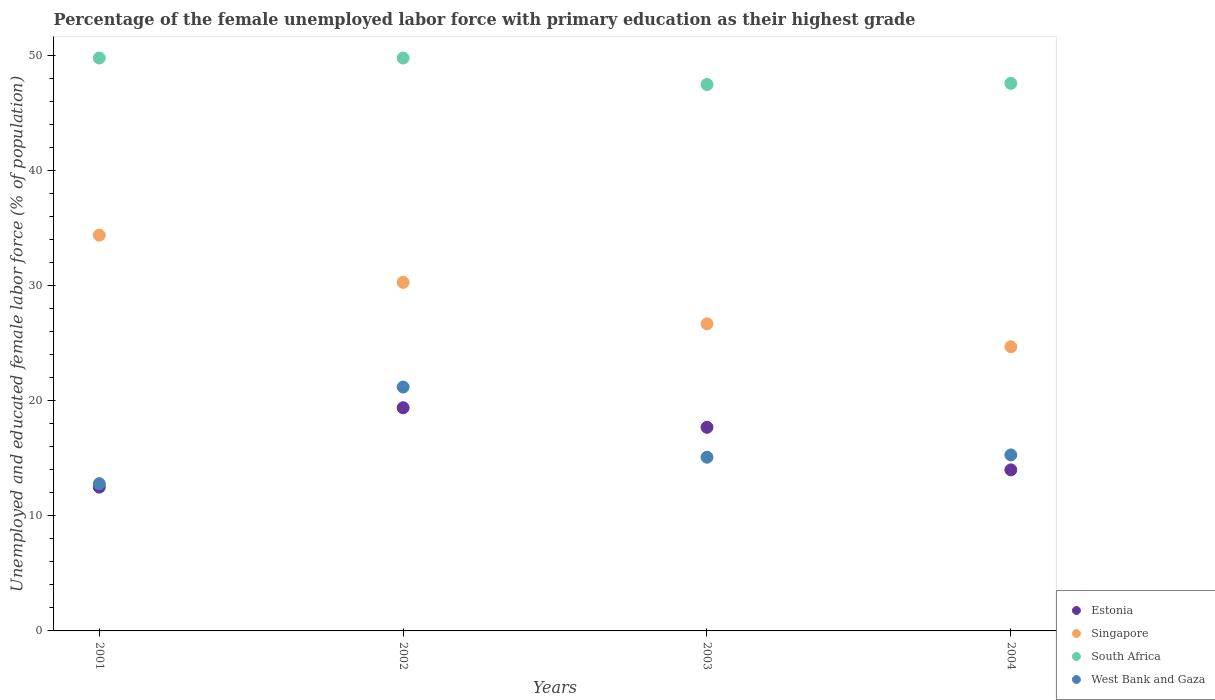How many different coloured dotlines are there?
Keep it short and to the point. 4. Is the number of dotlines equal to the number of legend labels?
Provide a short and direct response. Yes. What is the percentage of the unemployed female labor force with primary education in West Bank and Gaza in 2002?
Offer a very short reply. 21.2. Across all years, what is the maximum percentage of the unemployed female labor force with primary education in Singapore?
Offer a very short reply. 34.4. Across all years, what is the minimum percentage of the unemployed female labor force with primary education in South Africa?
Offer a very short reply. 47.5. In which year was the percentage of the unemployed female labor force with primary education in Singapore maximum?
Your response must be concise. 2001. What is the total percentage of the unemployed female labor force with primary education in South Africa in the graph?
Offer a very short reply. 194.7. What is the difference between the percentage of the unemployed female labor force with primary education in South Africa in 2001 and that in 2003?
Make the answer very short. 2.3. What is the difference between the percentage of the unemployed female labor force with primary education in Estonia in 2004 and the percentage of the unemployed female labor force with primary education in South Africa in 2002?
Provide a short and direct response. -35.8. What is the average percentage of the unemployed female labor force with primary education in Singapore per year?
Your answer should be very brief. 29.03. In the year 2004, what is the difference between the percentage of the unemployed female labor force with primary education in South Africa and percentage of the unemployed female labor force with primary education in Singapore?
Offer a very short reply. 22.9. What is the ratio of the percentage of the unemployed female labor force with primary education in Estonia in 2002 to that in 2004?
Your answer should be compact. 1.39. Is the percentage of the unemployed female labor force with primary education in South Africa in 2001 less than that in 2003?
Provide a short and direct response. No. Is the difference between the percentage of the unemployed female labor force with primary education in South Africa in 2002 and 2004 greater than the difference between the percentage of the unemployed female labor force with primary education in Singapore in 2002 and 2004?
Make the answer very short. No. What is the difference between the highest and the second highest percentage of the unemployed female labor force with primary education in South Africa?
Give a very brief answer. 0. What is the difference between the highest and the lowest percentage of the unemployed female labor force with primary education in South Africa?
Your response must be concise. 2.3. Is it the case that in every year, the sum of the percentage of the unemployed female labor force with primary education in Singapore and percentage of the unemployed female labor force with primary education in West Bank and Gaza  is greater than the sum of percentage of the unemployed female labor force with primary education in South Africa and percentage of the unemployed female labor force with primary education in Estonia?
Your answer should be compact. No. Is the percentage of the unemployed female labor force with primary education in Singapore strictly greater than the percentage of the unemployed female labor force with primary education in West Bank and Gaza over the years?
Your response must be concise. Yes. How many years are there in the graph?
Ensure brevity in your answer.  4. Does the graph contain any zero values?
Offer a very short reply. No. Does the graph contain grids?
Your response must be concise. No. Where does the legend appear in the graph?
Keep it short and to the point. Bottom right. How many legend labels are there?
Your response must be concise. 4. How are the legend labels stacked?
Your answer should be very brief. Vertical. What is the title of the graph?
Provide a short and direct response. Percentage of the female unemployed labor force with primary education as their highest grade. What is the label or title of the X-axis?
Offer a terse response. Years. What is the label or title of the Y-axis?
Make the answer very short. Unemployed and educated female labor force (% of population). What is the Unemployed and educated female labor force (% of population) of Estonia in 2001?
Make the answer very short. 12.5. What is the Unemployed and educated female labor force (% of population) of Singapore in 2001?
Your answer should be compact. 34.4. What is the Unemployed and educated female labor force (% of population) of South Africa in 2001?
Offer a very short reply. 49.8. What is the Unemployed and educated female labor force (% of population) in West Bank and Gaza in 2001?
Give a very brief answer. 12.8. What is the Unemployed and educated female labor force (% of population) of Estonia in 2002?
Offer a terse response. 19.4. What is the Unemployed and educated female labor force (% of population) in Singapore in 2002?
Provide a succinct answer. 30.3. What is the Unemployed and educated female labor force (% of population) in South Africa in 2002?
Make the answer very short. 49.8. What is the Unemployed and educated female labor force (% of population) of West Bank and Gaza in 2002?
Keep it short and to the point. 21.2. What is the Unemployed and educated female labor force (% of population) of Estonia in 2003?
Make the answer very short. 17.7. What is the Unemployed and educated female labor force (% of population) in Singapore in 2003?
Offer a very short reply. 26.7. What is the Unemployed and educated female labor force (% of population) in South Africa in 2003?
Offer a terse response. 47.5. What is the Unemployed and educated female labor force (% of population) of West Bank and Gaza in 2003?
Make the answer very short. 15.1. What is the Unemployed and educated female labor force (% of population) of Estonia in 2004?
Provide a short and direct response. 14. What is the Unemployed and educated female labor force (% of population) of Singapore in 2004?
Ensure brevity in your answer.  24.7. What is the Unemployed and educated female labor force (% of population) of South Africa in 2004?
Offer a very short reply. 47.6. What is the Unemployed and educated female labor force (% of population) in West Bank and Gaza in 2004?
Your answer should be very brief. 15.3. Across all years, what is the maximum Unemployed and educated female labor force (% of population) of Estonia?
Your answer should be compact. 19.4. Across all years, what is the maximum Unemployed and educated female labor force (% of population) in Singapore?
Offer a very short reply. 34.4. Across all years, what is the maximum Unemployed and educated female labor force (% of population) of South Africa?
Provide a succinct answer. 49.8. Across all years, what is the maximum Unemployed and educated female labor force (% of population) of West Bank and Gaza?
Provide a succinct answer. 21.2. Across all years, what is the minimum Unemployed and educated female labor force (% of population) in Estonia?
Ensure brevity in your answer.  12.5. Across all years, what is the minimum Unemployed and educated female labor force (% of population) of Singapore?
Ensure brevity in your answer.  24.7. Across all years, what is the minimum Unemployed and educated female labor force (% of population) of South Africa?
Offer a terse response. 47.5. Across all years, what is the minimum Unemployed and educated female labor force (% of population) of West Bank and Gaza?
Provide a short and direct response. 12.8. What is the total Unemployed and educated female labor force (% of population) of Estonia in the graph?
Keep it short and to the point. 63.6. What is the total Unemployed and educated female labor force (% of population) in Singapore in the graph?
Keep it short and to the point. 116.1. What is the total Unemployed and educated female labor force (% of population) in South Africa in the graph?
Your answer should be very brief. 194.7. What is the total Unemployed and educated female labor force (% of population) in West Bank and Gaza in the graph?
Provide a succinct answer. 64.4. What is the difference between the Unemployed and educated female labor force (% of population) in Estonia in 2001 and that in 2002?
Provide a short and direct response. -6.9. What is the difference between the Unemployed and educated female labor force (% of population) of Estonia in 2001 and that in 2003?
Your answer should be compact. -5.2. What is the difference between the Unemployed and educated female labor force (% of population) of Singapore in 2001 and that in 2003?
Your answer should be compact. 7.7. What is the difference between the Unemployed and educated female labor force (% of population) in South Africa in 2001 and that in 2003?
Your response must be concise. 2.3. What is the difference between the Unemployed and educated female labor force (% of population) in Estonia in 2001 and that in 2004?
Offer a very short reply. -1.5. What is the difference between the Unemployed and educated female labor force (% of population) of Singapore in 2001 and that in 2004?
Offer a very short reply. 9.7. What is the difference between the Unemployed and educated female labor force (% of population) in Singapore in 2002 and that in 2003?
Give a very brief answer. 3.6. What is the difference between the Unemployed and educated female labor force (% of population) in South Africa in 2002 and that in 2003?
Provide a succinct answer. 2.3. What is the difference between the Unemployed and educated female labor force (% of population) in Estonia in 2002 and that in 2004?
Offer a terse response. 5.4. What is the difference between the Unemployed and educated female labor force (% of population) in West Bank and Gaza in 2002 and that in 2004?
Provide a short and direct response. 5.9. What is the difference between the Unemployed and educated female labor force (% of population) in Estonia in 2003 and that in 2004?
Offer a very short reply. 3.7. What is the difference between the Unemployed and educated female labor force (% of population) in West Bank and Gaza in 2003 and that in 2004?
Provide a succinct answer. -0.2. What is the difference between the Unemployed and educated female labor force (% of population) of Estonia in 2001 and the Unemployed and educated female labor force (% of population) of Singapore in 2002?
Your response must be concise. -17.8. What is the difference between the Unemployed and educated female labor force (% of population) in Estonia in 2001 and the Unemployed and educated female labor force (% of population) in South Africa in 2002?
Offer a very short reply. -37.3. What is the difference between the Unemployed and educated female labor force (% of population) in Estonia in 2001 and the Unemployed and educated female labor force (% of population) in West Bank and Gaza in 2002?
Your answer should be compact. -8.7. What is the difference between the Unemployed and educated female labor force (% of population) in Singapore in 2001 and the Unemployed and educated female labor force (% of population) in South Africa in 2002?
Offer a very short reply. -15.4. What is the difference between the Unemployed and educated female labor force (% of population) in South Africa in 2001 and the Unemployed and educated female labor force (% of population) in West Bank and Gaza in 2002?
Keep it short and to the point. 28.6. What is the difference between the Unemployed and educated female labor force (% of population) of Estonia in 2001 and the Unemployed and educated female labor force (% of population) of South Africa in 2003?
Your answer should be compact. -35. What is the difference between the Unemployed and educated female labor force (% of population) in Estonia in 2001 and the Unemployed and educated female labor force (% of population) in West Bank and Gaza in 2003?
Give a very brief answer. -2.6. What is the difference between the Unemployed and educated female labor force (% of population) of Singapore in 2001 and the Unemployed and educated female labor force (% of population) of South Africa in 2003?
Your answer should be compact. -13.1. What is the difference between the Unemployed and educated female labor force (% of population) in Singapore in 2001 and the Unemployed and educated female labor force (% of population) in West Bank and Gaza in 2003?
Keep it short and to the point. 19.3. What is the difference between the Unemployed and educated female labor force (% of population) of South Africa in 2001 and the Unemployed and educated female labor force (% of population) of West Bank and Gaza in 2003?
Your answer should be compact. 34.7. What is the difference between the Unemployed and educated female labor force (% of population) of Estonia in 2001 and the Unemployed and educated female labor force (% of population) of Singapore in 2004?
Your response must be concise. -12.2. What is the difference between the Unemployed and educated female labor force (% of population) in Estonia in 2001 and the Unemployed and educated female labor force (% of population) in South Africa in 2004?
Provide a short and direct response. -35.1. What is the difference between the Unemployed and educated female labor force (% of population) of Estonia in 2001 and the Unemployed and educated female labor force (% of population) of West Bank and Gaza in 2004?
Your response must be concise. -2.8. What is the difference between the Unemployed and educated female labor force (% of population) in Singapore in 2001 and the Unemployed and educated female labor force (% of population) in South Africa in 2004?
Give a very brief answer. -13.2. What is the difference between the Unemployed and educated female labor force (% of population) of Singapore in 2001 and the Unemployed and educated female labor force (% of population) of West Bank and Gaza in 2004?
Your answer should be very brief. 19.1. What is the difference between the Unemployed and educated female labor force (% of population) in South Africa in 2001 and the Unemployed and educated female labor force (% of population) in West Bank and Gaza in 2004?
Provide a succinct answer. 34.5. What is the difference between the Unemployed and educated female labor force (% of population) of Estonia in 2002 and the Unemployed and educated female labor force (% of population) of Singapore in 2003?
Ensure brevity in your answer.  -7.3. What is the difference between the Unemployed and educated female labor force (% of population) of Estonia in 2002 and the Unemployed and educated female labor force (% of population) of South Africa in 2003?
Give a very brief answer. -28.1. What is the difference between the Unemployed and educated female labor force (% of population) in Singapore in 2002 and the Unemployed and educated female labor force (% of population) in South Africa in 2003?
Ensure brevity in your answer.  -17.2. What is the difference between the Unemployed and educated female labor force (% of population) of South Africa in 2002 and the Unemployed and educated female labor force (% of population) of West Bank and Gaza in 2003?
Offer a terse response. 34.7. What is the difference between the Unemployed and educated female labor force (% of population) of Estonia in 2002 and the Unemployed and educated female labor force (% of population) of Singapore in 2004?
Give a very brief answer. -5.3. What is the difference between the Unemployed and educated female labor force (% of population) of Estonia in 2002 and the Unemployed and educated female labor force (% of population) of South Africa in 2004?
Provide a succinct answer. -28.2. What is the difference between the Unemployed and educated female labor force (% of population) of Estonia in 2002 and the Unemployed and educated female labor force (% of population) of West Bank and Gaza in 2004?
Your answer should be compact. 4.1. What is the difference between the Unemployed and educated female labor force (% of population) of Singapore in 2002 and the Unemployed and educated female labor force (% of population) of South Africa in 2004?
Make the answer very short. -17.3. What is the difference between the Unemployed and educated female labor force (% of population) in South Africa in 2002 and the Unemployed and educated female labor force (% of population) in West Bank and Gaza in 2004?
Keep it short and to the point. 34.5. What is the difference between the Unemployed and educated female labor force (% of population) in Estonia in 2003 and the Unemployed and educated female labor force (% of population) in South Africa in 2004?
Your answer should be very brief. -29.9. What is the difference between the Unemployed and educated female labor force (% of population) in Singapore in 2003 and the Unemployed and educated female labor force (% of population) in South Africa in 2004?
Ensure brevity in your answer.  -20.9. What is the difference between the Unemployed and educated female labor force (% of population) in South Africa in 2003 and the Unemployed and educated female labor force (% of population) in West Bank and Gaza in 2004?
Your answer should be compact. 32.2. What is the average Unemployed and educated female labor force (% of population) in Estonia per year?
Offer a very short reply. 15.9. What is the average Unemployed and educated female labor force (% of population) in Singapore per year?
Give a very brief answer. 29.02. What is the average Unemployed and educated female labor force (% of population) of South Africa per year?
Offer a very short reply. 48.67. What is the average Unemployed and educated female labor force (% of population) of West Bank and Gaza per year?
Make the answer very short. 16.1. In the year 2001, what is the difference between the Unemployed and educated female labor force (% of population) of Estonia and Unemployed and educated female labor force (% of population) of Singapore?
Ensure brevity in your answer.  -21.9. In the year 2001, what is the difference between the Unemployed and educated female labor force (% of population) of Estonia and Unemployed and educated female labor force (% of population) of South Africa?
Your response must be concise. -37.3. In the year 2001, what is the difference between the Unemployed and educated female labor force (% of population) of Singapore and Unemployed and educated female labor force (% of population) of South Africa?
Provide a short and direct response. -15.4. In the year 2001, what is the difference between the Unemployed and educated female labor force (% of population) in Singapore and Unemployed and educated female labor force (% of population) in West Bank and Gaza?
Your answer should be compact. 21.6. In the year 2002, what is the difference between the Unemployed and educated female labor force (% of population) of Estonia and Unemployed and educated female labor force (% of population) of South Africa?
Your answer should be compact. -30.4. In the year 2002, what is the difference between the Unemployed and educated female labor force (% of population) in Singapore and Unemployed and educated female labor force (% of population) in South Africa?
Give a very brief answer. -19.5. In the year 2002, what is the difference between the Unemployed and educated female labor force (% of population) in Singapore and Unemployed and educated female labor force (% of population) in West Bank and Gaza?
Provide a succinct answer. 9.1. In the year 2002, what is the difference between the Unemployed and educated female labor force (% of population) of South Africa and Unemployed and educated female labor force (% of population) of West Bank and Gaza?
Provide a short and direct response. 28.6. In the year 2003, what is the difference between the Unemployed and educated female labor force (% of population) in Estonia and Unemployed and educated female labor force (% of population) in South Africa?
Give a very brief answer. -29.8. In the year 2003, what is the difference between the Unemployed and educated female labor force (% of population) of Singapore and Unemployed and educated female labor force (% of population) of South Africa?
Make the answer very short. -20.8. In the year 2003, what is the difference between the Unemployed and educated female labor force (% of population) in Singapore and Unemployed and educated female labor force (% of population) in West Bank and Gaza?
Keep it short and to the point. 11.6. In the year 2003, what is the difference between the Unemployed and educated female labor force (% of population) in South Africa and Unemployed and educated female labor force (% of population) in West Bank and Gaza?
Offer a very short reply. 32.4. In the year 2004, what is the difference between the Unemployed and educated female labor force (% of population) in Estonia and Unemployed and educated female labor force (% of population) in South Africa?
Provide a succinct answer. -33.6. In the year 2004, what is the difference between the Unemployed and educated female labor force (% of population) of Estonia and Unemployed and educated female labor force (% of population) of West Bank and Gaza?
Provide a short and direct response. -1.3. In the year 2004, what is the difference between the Unemployed and educated female labor force (% of population) in Singapore and Unemployed and educated female labor force (% of population) in South Africa?
Offer a very short reply. -22.9. In the year 2004, what is the difference between the Unemployed and educated female labor force (% of population) in Singapore and Unemployed and educated female labor force (% of population) in West Bank and Gaza?
Provide a short and direct response. 9.4. In the year 2004, what is the difference between the Unemployed and educated female labor force (% of population) of South Africa and Unemployed and educated female labor force (% of population) of West Bank and Gaza?
Your answer should be very brief. 32.3. What is the ratio of the Unemployed and educated female labor force (% of population) of Estonia in 2001 to that in 2002?
Provide a short and direct response. 0.64. What is the ratio of the Unemployed and educated female labor force (% of population) in Singapore in 2001 to that in 2002?
Ensure brevity in your answer.  1.14. What is the ratio of the Unemployed and educated female labor force (% of population) of West Bank and Gaza in 2001 to that in 2002?
Provide a short and direct response. 0.6. What is the ratio of the Unemployed and educated female labor force (% of population) in Estonia in 2001 to that in 2003?
Offer a terse response. 0.71. What is the ratio of the Unemployed and educated female labor force (% of population) in Singapore in 2001 to that in 2003?
Give a very brief answer. 1.29. What is the ratio of the Unemployed and educated female labor force (% of population) in South Africa in 2001 to that in 2003?
Your answer should be very brief. 1.05. What is the ratio of the Unemployed and educated female labor force (% of population) of West Bank and Gaza in 2001 to that in 2003?
Provide a short and direct response. 0.85. What is the ratio of the Unemployed and educated female labor force (% of population) in Estonia in 2001 to that in 2004?
Your response must be concise. 0.89. What is the ratio of the Unemployed and educated female labor force (% of population) of Singapore in 2001 to that in 2004?
Offer a terse response. 1.39. What is the ratio of the Unemployed and educated female labor force (% of population) of South Africa in 2001 to that in 2004?
Offer a terse response. 1.05. What is the ratio of the Unemployed and educated female labor force (% of population) of West Bank and Gaza in 2001 to that in 2004?
Keep it short and to the point. 0.84. What is the ratio of the Unemployed and educated female labor force (% of population) of Estonia in 2002 to that in 2003?
Your answer should be very brief. 1.1. What is the ratio of the Unemployed and educated female labor force (% of population) in Singapore in 2002 to that in 2003?
Your answer should be very brief. 1.13. What is the ratio of the Unemployed and educated female labor force (% of population) in South Africa in 2002 to that in 2003?
Provide a short and direct response. 1.05. What is the ratio of the Unemployed and educated female labor force (% of population) in West Bank and Gaza in 2002 to that in 2003?
Your answer should be very brief. 1.4. What is the ratio of the Unemployed and educated female labor force (% of population) in Estonia in 2002 to that in 2004?
Your response must be concise. 1.39. What is the ratio of the Unemployed and educated female labor force (% of population) of Singapore in 2002 to that in 2004?
Offer a terse response. 1.23. What is the ratio of the Unemployed and educated female labor force (% of population) of South Africa in 2002 to that in 2004?
Give a very brief answer. 1.05. What is the ratio of the Unemployed and educated female labor force (% of population) in West Bank and Gaza in 2002 to that in 2004?
Keep it short and to the point. 1.39. What is the ratio of the Unemployed and educated female labor force (% of population) in Estonia in 2003 to that in 2004?
Your response must be concise. 1.26. What is the ratio of the Unemployed and educated female labor force (% of population) of Singapore in 2003 to that in 2004?
Provide a succinct answer. 1.08. What is the ratio of the Unemployed and educated female labor force (% of population) of West Bank and Gaza in 2003 to that in 2004?
Make the answer very short. 0.99. What is the difference between the highest and the second highest Unemployed and educated female labor force (% of population) in Estonia?
Make the answer very short. 1.7. What is the difference between the highest and the second highest Unemployed and educated female labor force (% of population) in Singapore?
Make the answer very short. 4.1. What is the difference between the highest and the second highest Unemployed and educated female labor force (% of population) in South Africa?
Give a very brief answer. 0. What is the difference between the highest and the lowest Unemployed and educated female labor force (% of population) in Estonia?
Ensure brevity in your answer.  6.9. What is the difference between the highest and the lowest Unemployed and educated female labor force (% of population) of Singapore?
Your response must be concise. 9.7. 